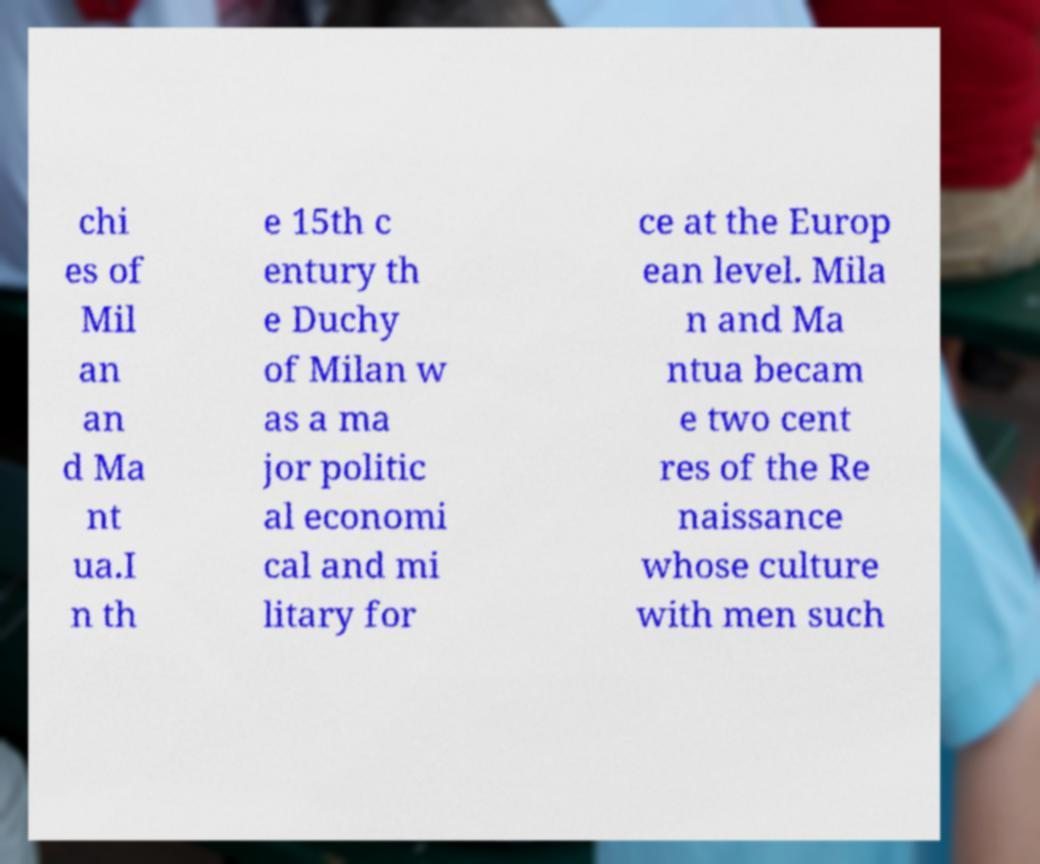I need the written content from this picture converted into text. Can you do that? chi es of Mil an an d Ma nt ua.I n th e 15th c entury th e Duchy of Milan w as a ma jor politic al economi cal and mi litary for ce at the Europ ean level. Mila n and Ma ntua becam e two cent res of the Re naissance whose culture with men such 